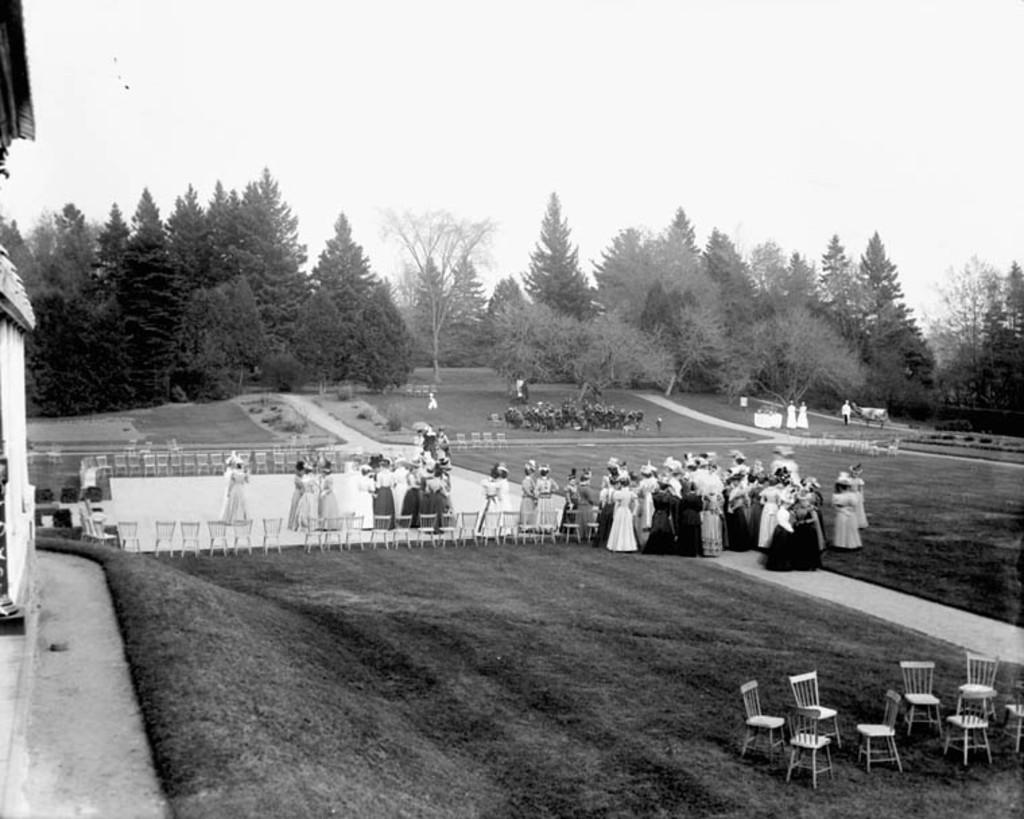What type of furniture is present in the image? There are chairs in the image. Who or what can be seen in the image? There are people in the image. What type of natural scenery is visible in the image? There are trees in the image. What is the color scheme of the image? The image is in black and white. Can you see the friend of the person in the image? There is no mention of a friend in the image, so it cannot be determined if a friend is present. What type of mountain is visible in the image? There is no mountain present in the image; it features chairs, people, and trees. 